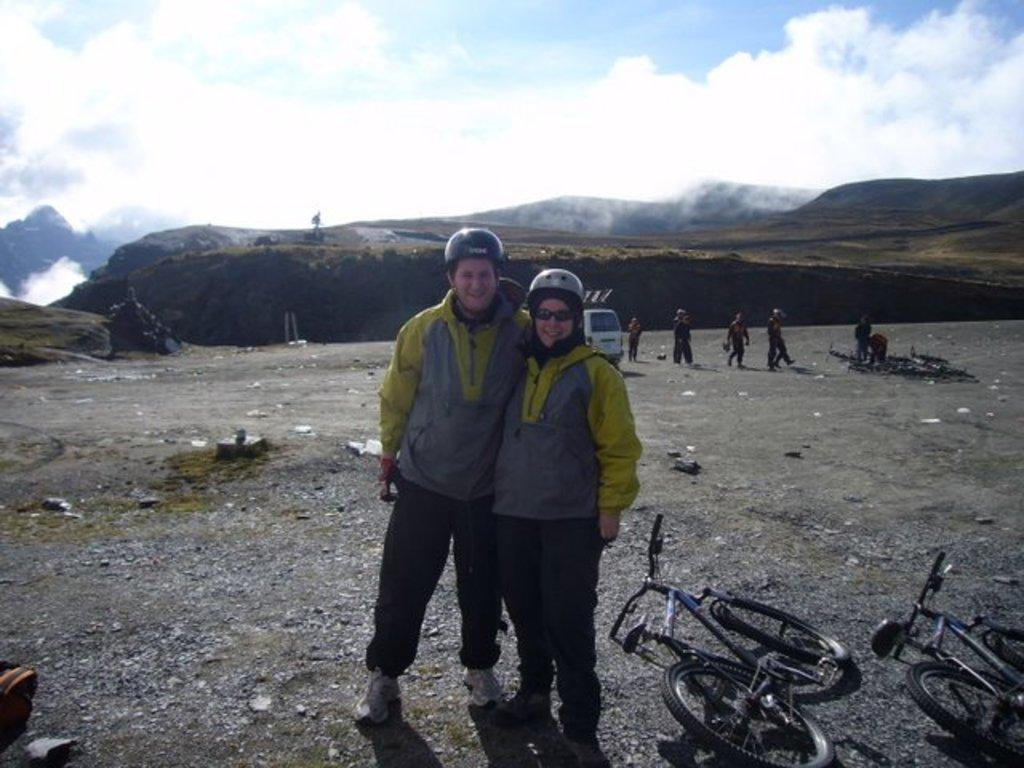Who or what is present in the image? There are people in the image. What type of vehicles can be seen in the image? There are cycles in the image. What type of terrain is visible in the image? There is sand and grass in the image. What can be seen in the background of the image? There are mountains and trees in the background of the image. What part of the natural environment is visible in the image? The sky is visible in the image. What type of drug is being sold in the image? There is no indication of any drug being sold or present in the image. 